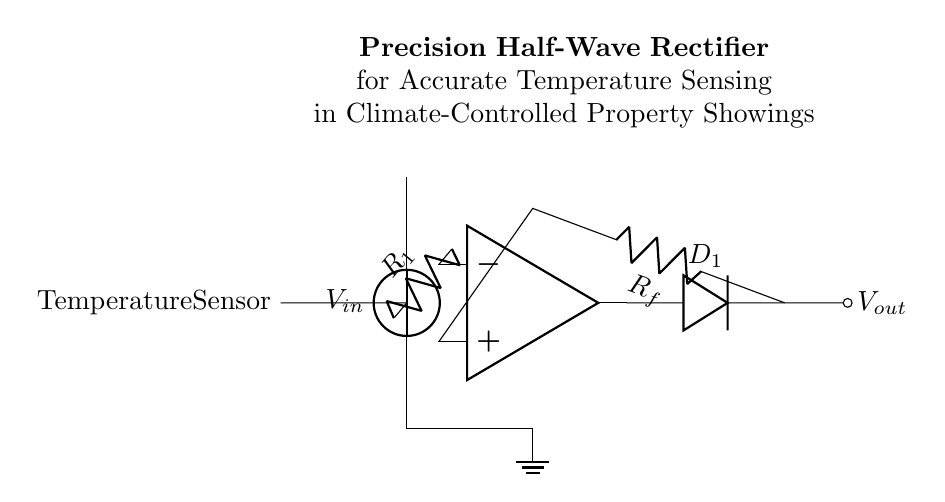What is the main purpose of this circuit? The main purpose of the circuit is to accurately convert the AC signal from a temperature sensor into a usable DC signal. This is necessary for reliable temperature measurements in climate-controlled property showings.
Answer: Accurate temperature sensing What component serves as the input to the op-amp? The input to the op-amp is the resistor labeled R1. It connects the input voltage from the temperature sensor to the inverting terminal of the op-amp.
Answer: R1 How many diodes are present in the circuit? There is one diode labeled D1 in the circuit. It is positioned to allow current to pass from the op-amp output while blocking reverse flow, essential for the rectification process.
Answer: One What type of rectifier is this circuit implementing? The circuit implements a half-wave rectifier, which allows only one half of the AC waveform to pass through, eliminating the negative portion. This is indicated by the configuration with a single diode in the circuit.
Answer: Half-wave How does the feedback resistor affect the circuit? The feedback resistor Rf sets the gain of the op-amp in this configuration, determining how the output voltage is related to the input voltage, thus affecting the accuracy and the efficiency of the rectification process.
Answer: Sets gain What is the output voltage represented by? The output voltage, labeled Vout, is the rectified DC signal that results from the operation of the precision half-wave rectifier, allowing for precise temperature measurements.
Answer: Vout 